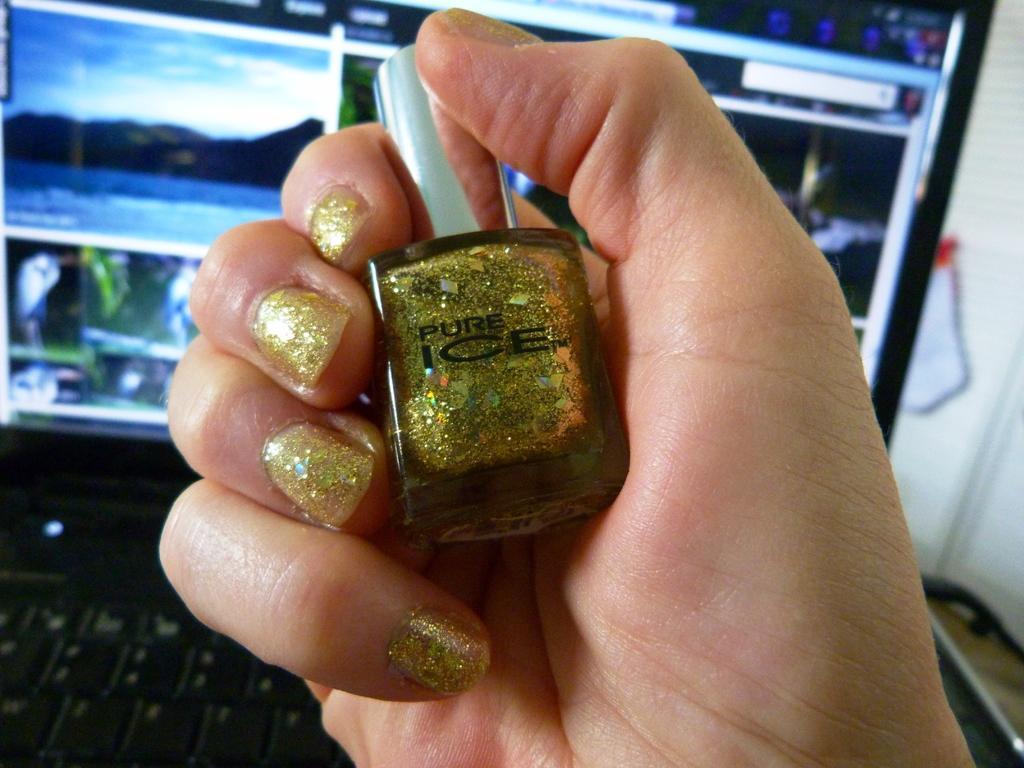How would you summarize this image in a sentence or two? In this image I see a person's hand who is holding a nail polish and I see that the nail polish is of golden in color and I see 2 words written over here. In the background I see a laptop and on the screen I see few pictures and I see that it is blurred in the background and I see the white color thing over here. 